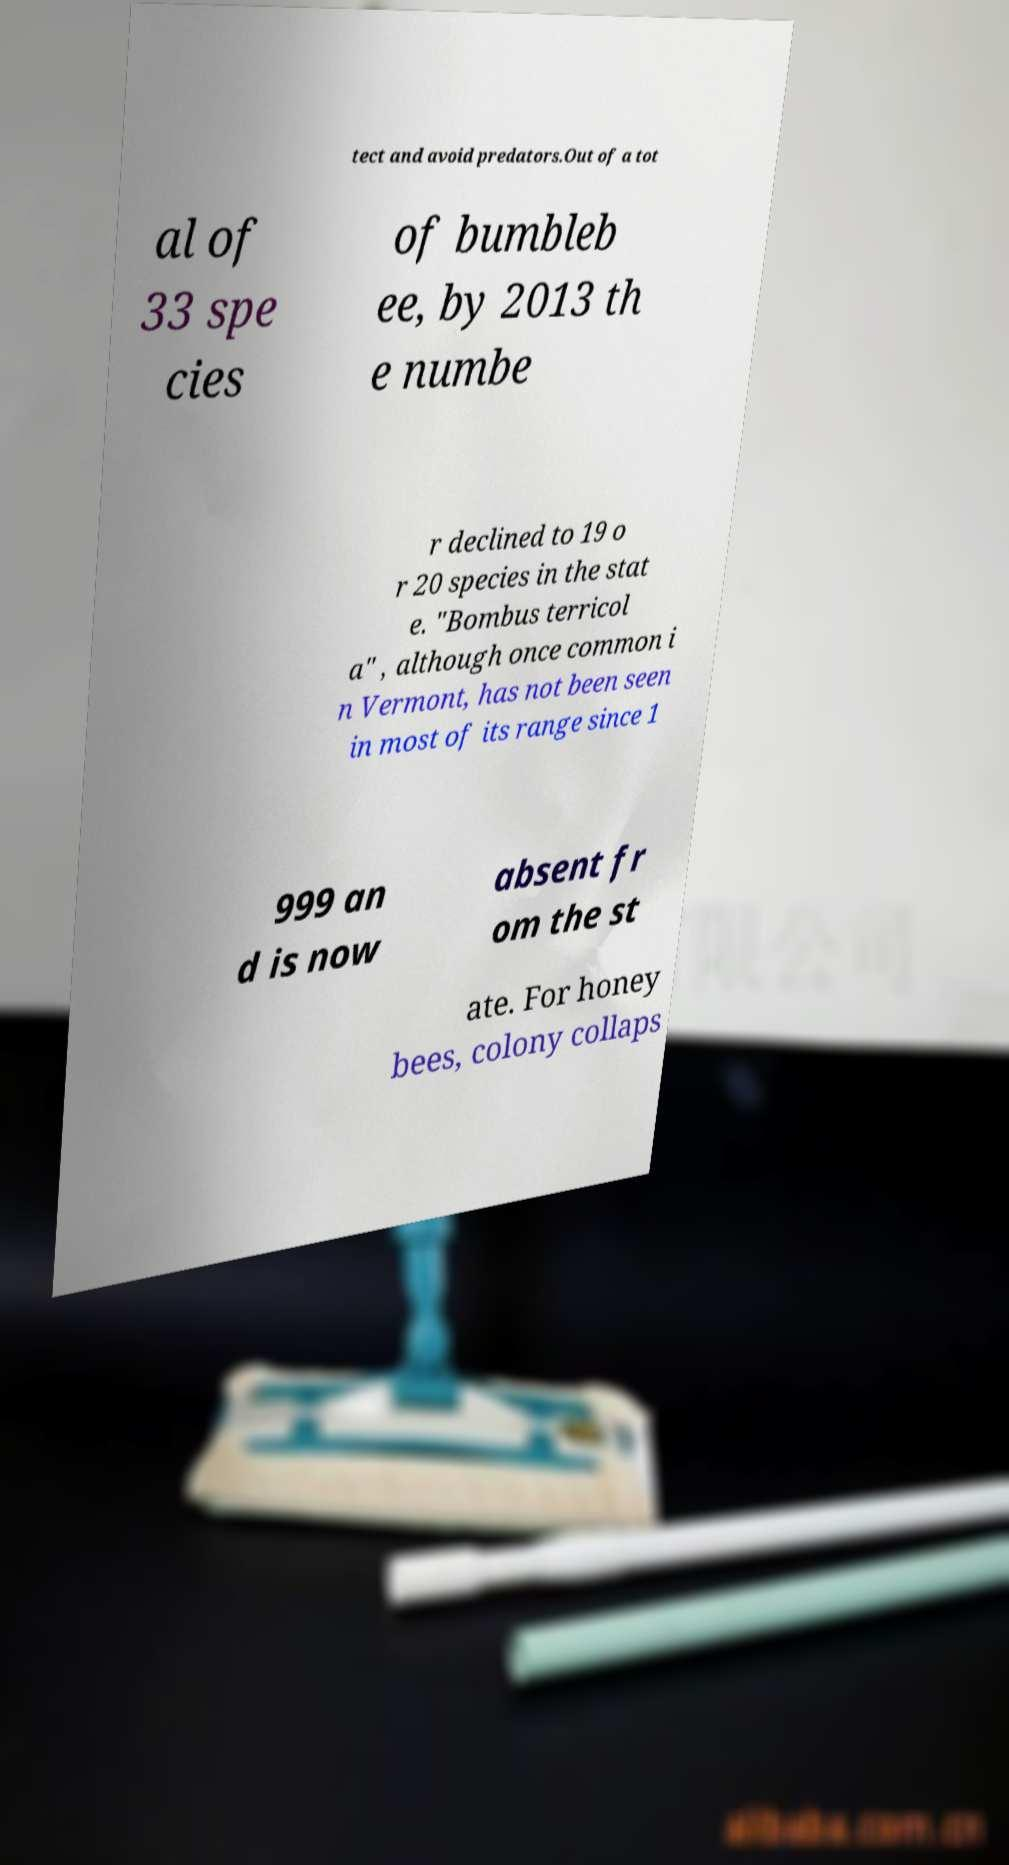I need the written content from this picture converted into text. Can you do that? tect and avoid predators.Out of a tot al of 33 spe cies of bumbleb ee, by 2013 th e numbe r declined to 19 o r 20 species in the stat e. "Bombus terricol a" , although once common i n Vermont, has not been seen in most of its range since 1 999 an d is now absent fr om the st ate. For honey bees, colony collaps 